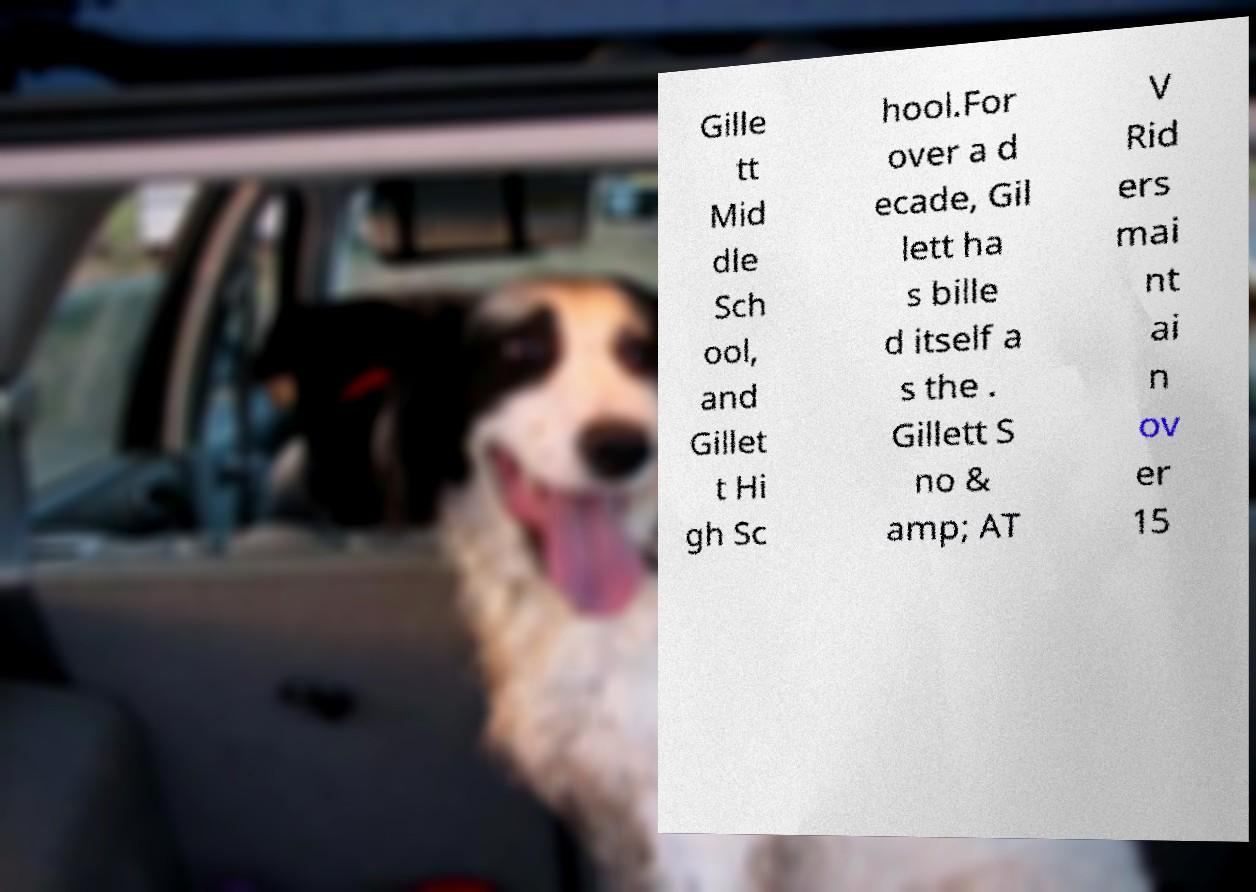Please read and relay the text visible in this image. What does it say? Gille tt Mid dle Sch ool, and Gillet t Hi gh Sc hool.For over a d ecade, Gil lett ha s bille d itself a s the . Gillett S no & amp; AT V Rid ers mai nt ai n ov er 15 